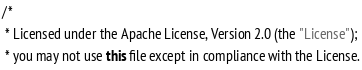<code> <loc_0><loc_0><loc_500><loc_500><_Java_>/*
 * Licensed under the Apache License, Version 2.0 (the "License");
 * you may not use this file except in compliance with the License.</code> 